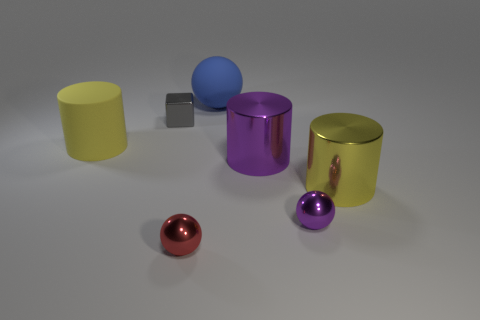Are there any blue things left of the big yellow matte cylinder?
Keep it short and to the point. No. What is the size of the yellow cylinder that is to the right of the sphere that is behind the yellow thing that is to the left of the gray thing?
Your answer should be compact. Large. Does the small shiny thing that is right of the large blue sphere have the same shape as the shiny object that is behind the yellow matte cylinder?
Provide a short and direct response. No. The red shiny object that is the same shape as the large blue object is what size?
Keep it short and to the point. Small. How many big yellow things have the same material as the small cube?
Offer a terse response. 1. What material is the purple sphere?
Keep it short and to the point. Metal. What is the shape of the large yellow object that is on the right side of the yellow thing that is on the left side of the large purple object?
Provide a short and direct response. Cylinder. What shape is the yellow object left of the red metallic thing?
Provide a succinct answer. Cylinder. How many other spheres have the same color as the large rubber ball?
Your answer should be very brief. 0. What is the color of the big matte cylinder?
Offer a very short reply. Yellow. 